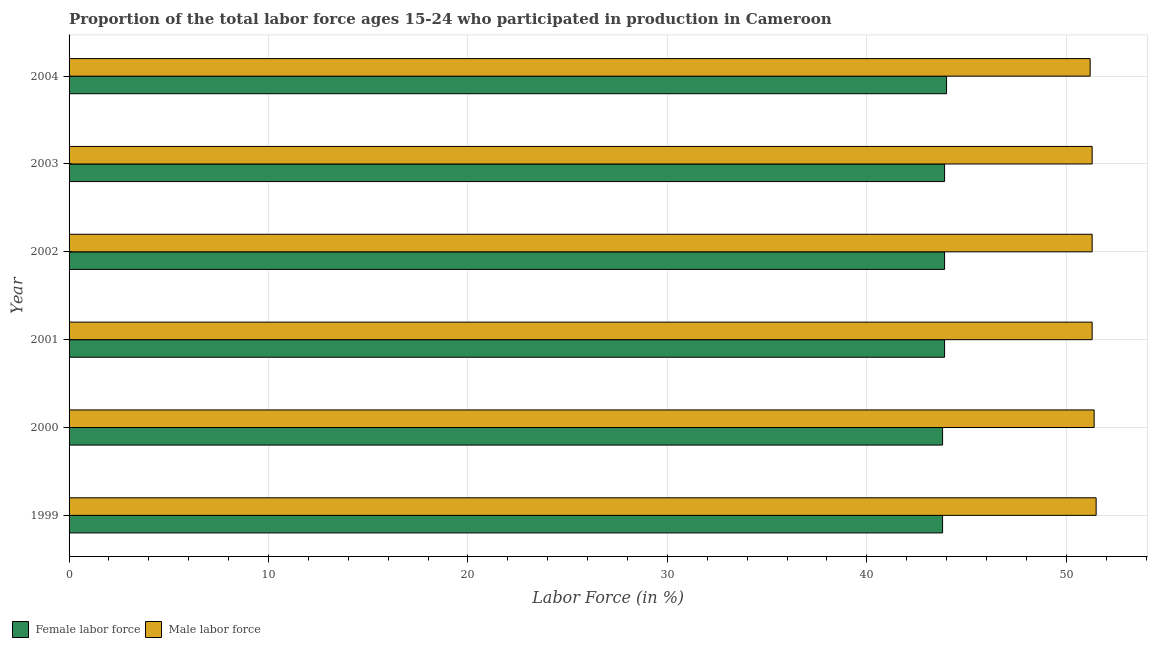How many groups of bars are there?
Your answer should be very brief. 6. Are the number of bars per tick equal to the number of legend labels?
Your answer should be very brief. Yes. How many bars are there on the 6th tick from the bottom?
Your answer should be compact. 2. What is the percentage of female labor force in 2003?
Ensure brevity in your answer.  43.9. Across all years, what is the maximum percentage of male labour force?
Give a very brief answer. 51.5. Across all years, what is the minimum percentage of female labor force?
Your response must be concise. 43.8. In which year was the percentage of male labour force minimum?
Your response must be concise. 2004. What is the total percentage of female labor force in the graph?
Provide a short and direct response. 263.3. What is the difference between the percentage of male labour force in 1999 and that in 2001?
Your answer should be compact. 0.2. What is the difference between the percentage of male labour force in 2004 and the percentage of female labor force in 2002?
Your answer should be very brief. 7.3. What is the average percentage of female labor force per year?
Provide a succinct answer. 43.88. In the year 2004, what is the difference between the percentage of male labour force and percentage of female labor force?
Offer a terse response. 7.2. In how many years, is the percentage of male labour force greater than 30 %?
Your answer should be very brief. 6. In how many years, is the percentage of male labour force greater than the average percentage of male labour force taken over all years?
Provide a short and direct response. 2. Is the sum of the percentage of female labor force in 2000 and 2002 greater than the maximum percentage of male labour force across all years?
Your answer should be compact. Yes. What does the 1st bar from the top in 1999 represents?
Keep it short and to the point. Male labor force. What does the 1st bar from the bottom in 2003 represents?
Your answer should be very brief. Female labor force. How many years are there in the graph?
Make the answer very short. 6. What is the difference between two consecutive major ticks on the X-axis?
Your answer should be compact. 10. Are the values on the major ticks of X-axis written in scientific E-notation?
Give a very brief answer. No. Does the graph contain grids?
Offer a very short reply. Yes. Where does the legend appear in the graph?
Give a very brief answer. Bottom left. How many legend labels are there?
Ensure brevity in your answer.  2. What is the title of the graph?
Your answer should be very brief. Proportion of the total labor force ages 15-24 who participated in production in Cameroon. What is the label or title of the X-axis?
Offer a very short reply. Labor Force (in %). What is the Labor Force (in %) of Female labor force in 1999?
Provide a succinct answer. 43.8. What is the Labor Force (in %) in Male labor force in 1999?
Ensure brevity in your answer.  51.5. What is the Labor Force (in %) of Female labor force in 2000?
Make the answer very short. 43.8. What is the Labor Force (in %) of Male labor force in 2000?
Your response must be concise. 51.4. What is the Labor Force (in %) in Female labor force in 2001?
Offer a very short reply. 43.9. What is the Labor Force (in %) of Male labor force in 2001?
Give a very brief answer. 51.3. What is the Labor Force (in %) in Female labor force in 2002?
Your answer should be compact. 43.9. What is the Labor Force (in %) in Male labor force in 2002?
Your response must be concise. 51.3. What is the Labor Force (in %) of Female labor force in 2003?
Your response must be concise. 43.9. What is the Labor Force (in %) in Male labor force in 2003?
Your response must be concise. 51.3. What is the Labor Force (in %) of Female labor force in 2004?
Keep it short and to the point. 44. What is the Labor Force (in %) of Male labor force in 2004?
Make the answer very short. 51.2. Across all years, what is the maximum Labor Force (in %) of Female labor force?
Provide a short and direct response. 44. Across all years, what is the maximum Labor Force (in %) of Male labor force?
Your answer should be very brief. 51.5. Across all years, what is the minimum Labor Force (in %) of Female labor force?
Make the answer very short. 43.8. Across all years, what is the minimum Labor Force (in %) of Male labor force?
Your answer should be very brief. 51.2. What is the total Labor Force (in %) of Female labor force in the graph?
Offer a very short reply. 263.3. What is the total Labor Force (in %) of Male labor force in the graph?
Offer a terse response. 308. What is the difference between the Labor Force (in %) in Male labor force in 1999 and that in 2001?
Offer a terse response. 0.2. What is the difference between the Labor Force (in %) in Male labor force in 1999 and that in 2002?
Provide a short and direct response. 0.2. What is the difference between the Labor Force (in %) in Female labor force in 1999 and that in 2003?
Offer a very short reply. -0.1. What is the difference between the Labor Force (in %) of Male labor force in 1999 and that in 2003?
Offer a very short reply. 0.2. What is the difference between the Labor Force (in %) in Male labor force in 1999 and that in 2004?
Offer a terse response. 0.3. What is the difference between the Labor Force (in %) in Female labor force in 2000 and that in 2001?
Provide a short and direct response. -0.1. What is the difference between the Labor Force (in %) of Male labor force in 2000 and that in 2001?
Make the answer very short. 0.1. What is the difference between the Labor Force (in %) of Female labor force in 2000 and that in 2002?
Your answer should be very brief. -0.1. What is the difference between the Labor Force (in %) in Male labor force in 2000 and that in 2002?
Offer a very short reply. 0.1. What is the difference between the Labor Force (in %) of Female labor force in 2000 and that in 2003?
Give a very brief answer. -0.1. What is the difference between the Labor Force (in %) in Male labor force in 2000 and that in 2003?
Provide a succinct answer. 0.1. What is the difference between the Labor Force (in %) in Male labor force in 2001 and that in 2003?
Offer a very short reply. 0. What is the difference between the Labor Force (in %) in Female labor force in 2001 and that in 2004?
Your answer should be very brief. -0.1. What is the difference between the Labor Force (in %) in Male labor force in 2001 and that in 2004?
Your answer should be compact. 0.1. What is the difference between the Labor Force (in %) in Female labor force in 2003 and that in 2004?
Ensure brevity in your answer.  -0.1. What is the difference between the Labor Force (in %) in Female labor force in 1999 and the Labor Force (in %) in Male labor force in 2002?
Ensure brevity in your answer.  -7.5. What is the difference between the Labor Force (in %) of Female labor force in 1999 and the Labor Force (in %) of Male labor force in 2004?
Your answer should be compact. -7.4. What is the difference between the Labor Force (in %) of Female labor force in 2000 and the Labor Force (in %) of Male labor force in 2001?
Provide a short and direct response. -7.5. What is the difference between the Labor Force (in %) of Female labor force in 2000 and the Labor Force (in %) of Male labor force in 2002?
Offer a terse response. -7.5. What is the difference between the Labor Force (in %) in Female labor force in 2000 and the Labor Force (in %) in Male labor force in 2004?
Give a very brief answer. -7.4. What is the difference between the Labor Force (in %) of Female labor force in 2002 and the Labor Force (in %) of Male labor force in 2003?
Your response must be concise. -7.4. What is the difference between the Labor Force (in %) in Female labor force in 2002 and the Labor Force (in %) in Male labor force in 2004?
Offer a terse response. -7.3. What is the average Labor Force (in %) in Female labor force per year?
Ensure brevity in your answer.  43.88. What is the average Labor Force (in %) in Male labor force per year?
Your response must be concise. 51.33. In the year 1999, what is the difference between the Labor Force (in %) of Female labor force and Labor Force (in %) of Male labor force?
Keep it short and to the point. -7.7. In the year 2001, what is the difference between the Labor Force (in %) of Female labor force and Labor Force (in %) of Male labor force?
Ensure brevity in your answer.  -7.4. In the year 2003, what is the difference between the Labor Force (in %) of Female labor force and Labor Force (in %) of Male labor force?
Offer a terse response. -7.4. In the year 2004, what is the difference between the Labor Force (in %) of Female labor force and Labor Force (in %) of Male labor force?
Your response must be concise. -7.2. What is the ratio of the Labor Force (in %) of Female labor force in 1999 to that in 2000?
Give a very brief answer. 1. What is the ratio of the Labor Force (in %) in Female labor force in 1999 to that in 2001?
Provide a succinct answer. 1. What is the ratio of the Labor Force (in %) of Male labor force in 1999 to that in 2004?
Provide a succinct answer. 1.01. What is the ratio of the Labor Force (in %) in Female labor force in 2000 to that in 2001?
Make the answer very short. 1. What is the ratio of the Labor Force (in %) of Female labor force in 2000 to that in 2003?
Give a very brief answer. 1. What is the ratio of the Labor Force (in %) of Male labor force in 2000 to that in 2003?
Provide a short and direct response. 1. What is the ratio of the Labor Force (in %) of Male labor force in 2001 to that in 2002?
Your response must be concise. 1. What is the ratio of the Labor Force (in %) in Female labor force in 2001 to that in 2003?
Your answer should be very brief. 1. What is the ratio of the Labor Force (in %) of Female labor force in 2002 to that in 2003?
Ensure brevity in your answer.  1. What is the ratio of the Labor Force (in %) of Female labor force in 2002 to that in 2004?
Give a very brief answer. 1. What is the ratio of the Labor Force (in %) of Female labor force in 2003 to that in 2004?
Your answer should be compact. 1. What is the difference between the highest and the second highest Labor Force (in %) in Male labor force?
Keep it short and to the point. 0.1. 